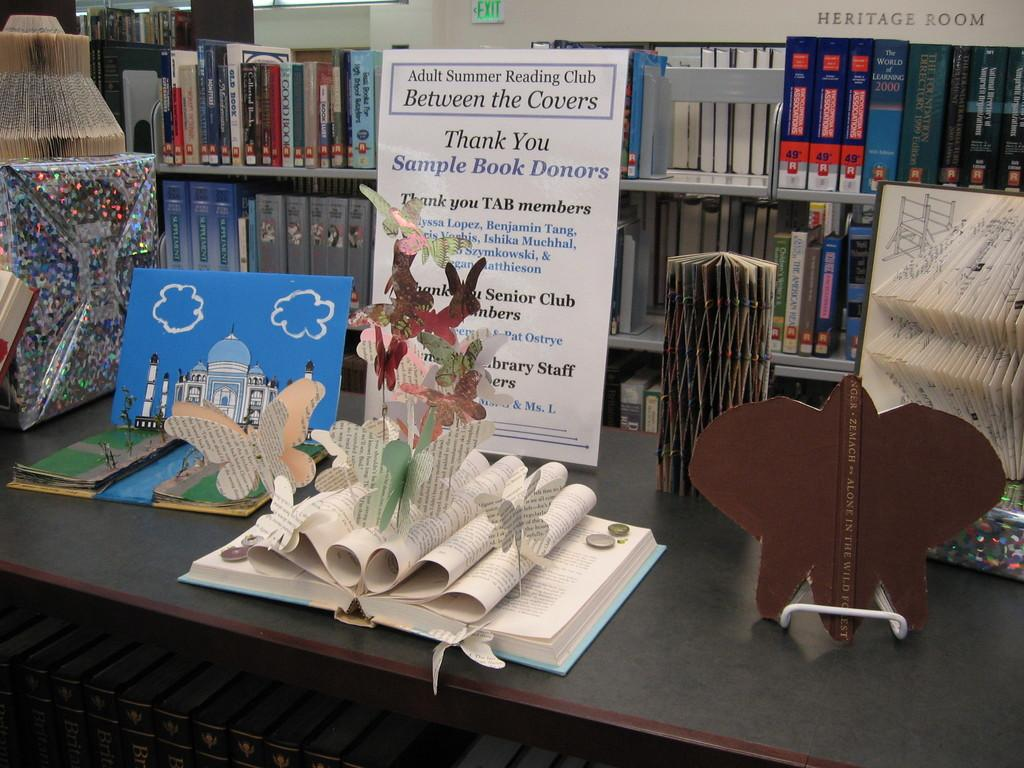What type of objects can be seen on the table in the image? There are books, a paper, and other items on the table in the image. Can you describe the arrangement of the books in the image? The books are arranged in an order in the background of the image. What other items might be present on the table, based on the given facts? There are other items on the table, but their specific nature is not mentioned in the facts. What type of hospital is depicted in the image? There is no hospital present in the image; it features books, a paper, and other items on a table. How does the self-awareness of the journey impact the arrangement of the books in the image? The image does not depict a journey or self-awareness, and therefore these concepts do not impact the arrangement of the books. 